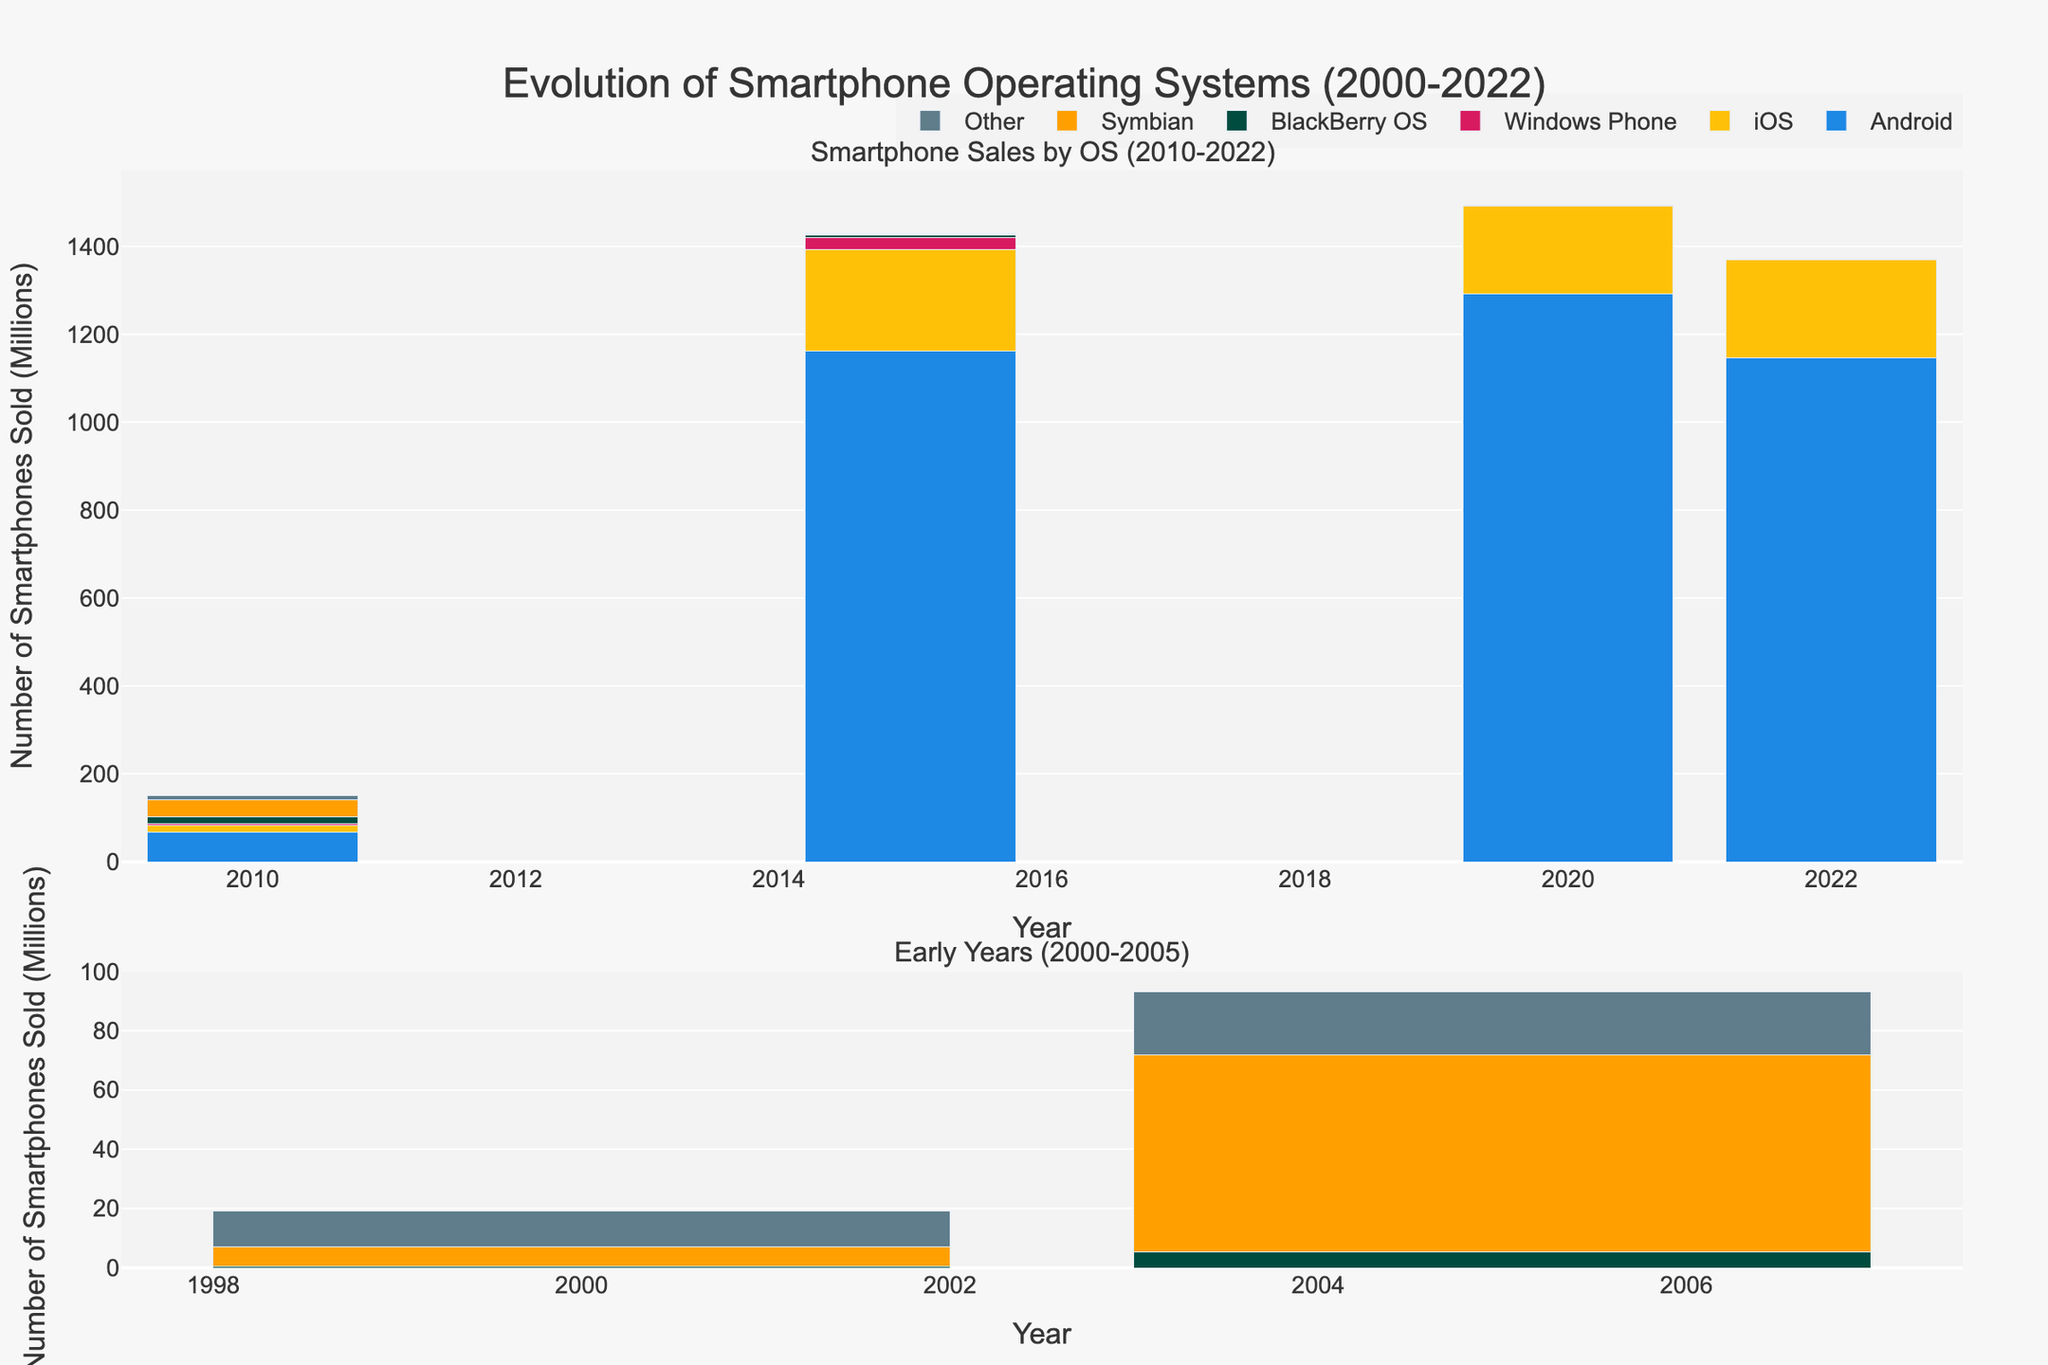How many Android smartphones were sold in 2020? Look at the bar for Android in the year 2020 and read the value.
Answer: 1292.3 million Which operating system had the highest sales in 2010? Compare the heights of the bars for each operating system in 2010. Android has the tallest bar.
Answer: Android What is the total number of smartphones sold by BlackBerry OS across all years shown? Sum the values of BlackBerry OS for all the years: 0.3 (2000) + 5.2 (2005) + 16.1 (2010) + 5.9 (2015) + 0 (2020) + 0 (2022).
Answer: 27.5 million Which operating system saw the largest drop in sales from 2015 to 2022? Calculate the difference in sales for each OS between 2015 and 2022, then compare them. Symbian drops from 0.5 to 0, iOS drops from 231.5 to 224.3, Windows Phone drops from 27.8 to 0, BlackBerry OS drops from 5.9 to 0, Android drops from 1161.1 to 1145.7, and Other drops from 2.6 to 0.9. Windows Phone has the largest drop.
Answer: Windows Phone Which year had the least total number of smartphones sold across all operating systems? Sum the values for each year and compare: 0 + 0 + 0 + 0.3 + 6.7 + 12.1 (2000), 0 + 0 + 0 + 5.2 + 66.8 + 21.3 (2005), 67.2 + 15.6 + 4.2 + 16.1 + 37.6 + 9.8 (2010), 1161.1 + 231.5 + 27.8 + 5.9 + 0.5 + 2.6 (2015), 1292.3 + 199.8 + 0.1 + 0 + 0 + 1.4 (2020), 1145.7 + 224.3 + 0 + 0 + 0 + 0.9 (2022). 2000 has the least total.
Answer: 2000 In what year did iOS have its highest sales? Compare the heights of the iOS bars across all years.
Answer: 2015 Comparing Android and iOS, which had more total sales from 2010 to 2022? Sum the values for Android (67.2 + 1161.1 + 1292.3 + 1145.7) and iOS (15.6 + 231.5 + 199.8 + 224.3) from 2010 to 2022. Android total is 3666.3, and iOS total is 671.2.
Answer: Android Which operating systems had zero sales in 2022? Look at the bars for each OS in 2022 and identify those with zero height. Windows Phone and BlackBerry OS have zero sales.
Answer: Windows Phone, BlackBerry OS What is the difference in the number of smartphones sold by Symbian between 2005 and 2010? Subtract the 2010 Symbian value from the 2005 value: 66.8 (2005) - 37.6 (2010).
Answer: 29.2 million 